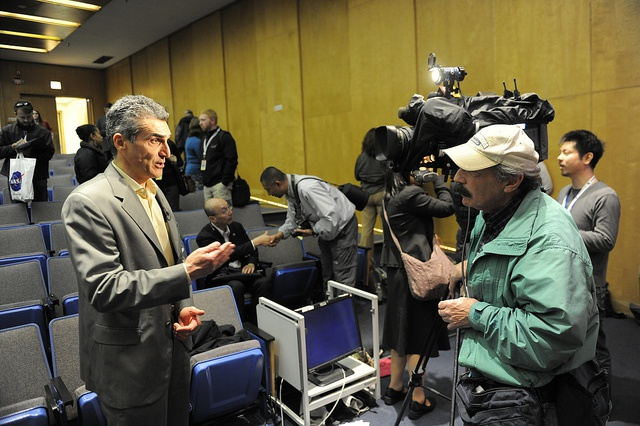Describe the objects in this image and their specific colors. I can see people in black, gray, turquoise, and darkgray tones, people in black, darkgray, gray, and tan tones, people in black and gray tones, people in black, gray, and darkgray tones, and people in black, gray, darkgray, and lightgray tones in this image. 